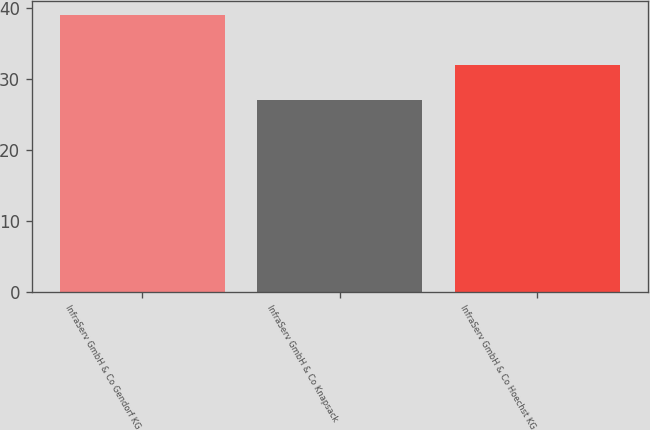Convert chart. <chart><loc_0><loc_0><loc_500><loc_500><bar_chart><fcel>InfraServ GmbH & Co Gendorf KG<fcel>InfraServ GmbH & Co Knapsack<fcel>InfraServ GmbH & Co Hoechst KG<nl><fcel>39<fcel>27<fcel>32<nl></chart> 